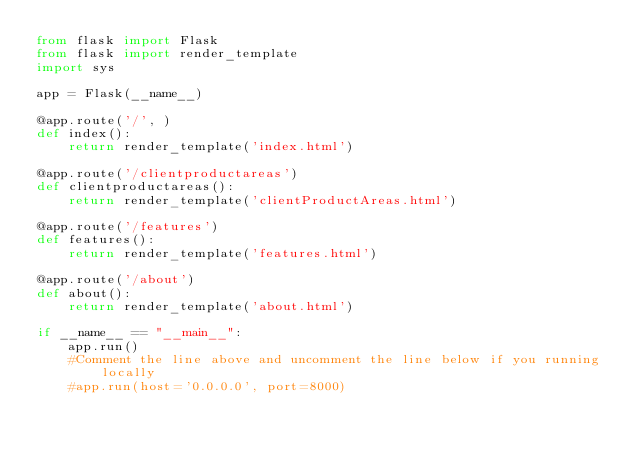Convert code to text. <code><loc_0><loc_0><loc_500><loc_500><_Python_>from flask import Flask
from flask import render_template
import sys

app = Flask(__name__)

@app.route('/', )
def index():
    return render_template('index.html')

@app.route('/clientproductareas')
def clientproductareas():
    return render_template('clientProductAreas.html')

@app.route('/features')
def features():
    return render_template('features.html')

@app.route('/about')
def about():
    return render_template('about.html')                    

if __name__ == "__main__":
    app.run()
    #Comment the line above and uncomment the line below if you running locally
	#app.run(host='0.0.0.0', port=8000)</code> 